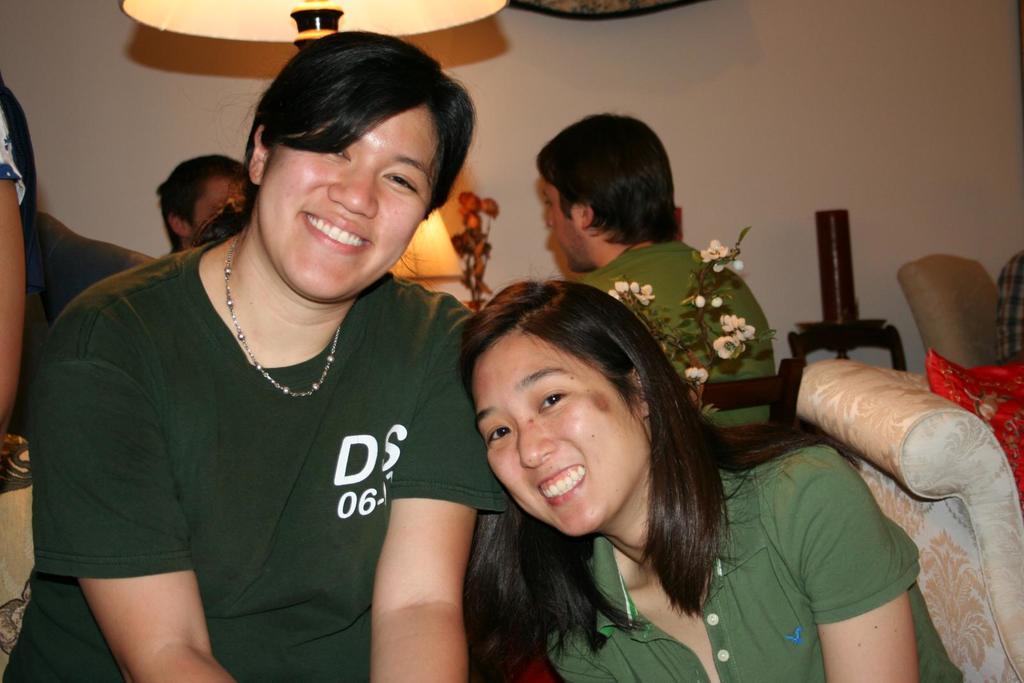In one or two sentences, can you explain what this image depicts? In this image I can see there are group of people and sofa set and flowers and chairs and lamp and the wall visible , in the foreground I can see there are two persons both are wearing a green color dress and both are smiling. 